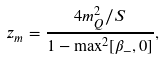Convert formula to latex. <formula><loc_0><loc_0><loc_500><loc_500>z _ { m } = \frac { 4 m _ { Q } ^ { 2 } / S } { 1 - \max ^ { 2 } [ \beta _ { - } , 0 ] } ,</formula> 